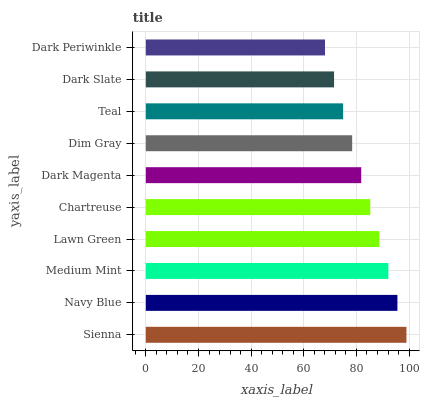Is Dark Periwinkle the minimum?
Answer yes or no. Yes. Is Sienna the maximum?
Answer yes or no. Yes. Is Navy Blue the minimum?
Answer yes or no. No. Is Navy Blue the maximum?
Answer yes or no. No. Is Sienna greater than Navy Blue?
Answer yes or no. Yes. Is Navy Blue less than Sienna?
Answer yes or no. Yes. Is Navy Blue greater than Sienna?
Answer yes or no. No. Is Sienna less than Navy Blue?
Answer yes or no. No. Is Chartreuse the high median?
Answer yes or no. Yes. Is Dark Magenta the low median?
Answer yes or no. Yes. Is Medium Mint the high median?
Answer yes or no. No. Is Dark Slate the low median?
Answer yes or no. No. 